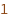<code> <loc_0><loc_0><loc_500><loc_500><_SQL_>
</code> 